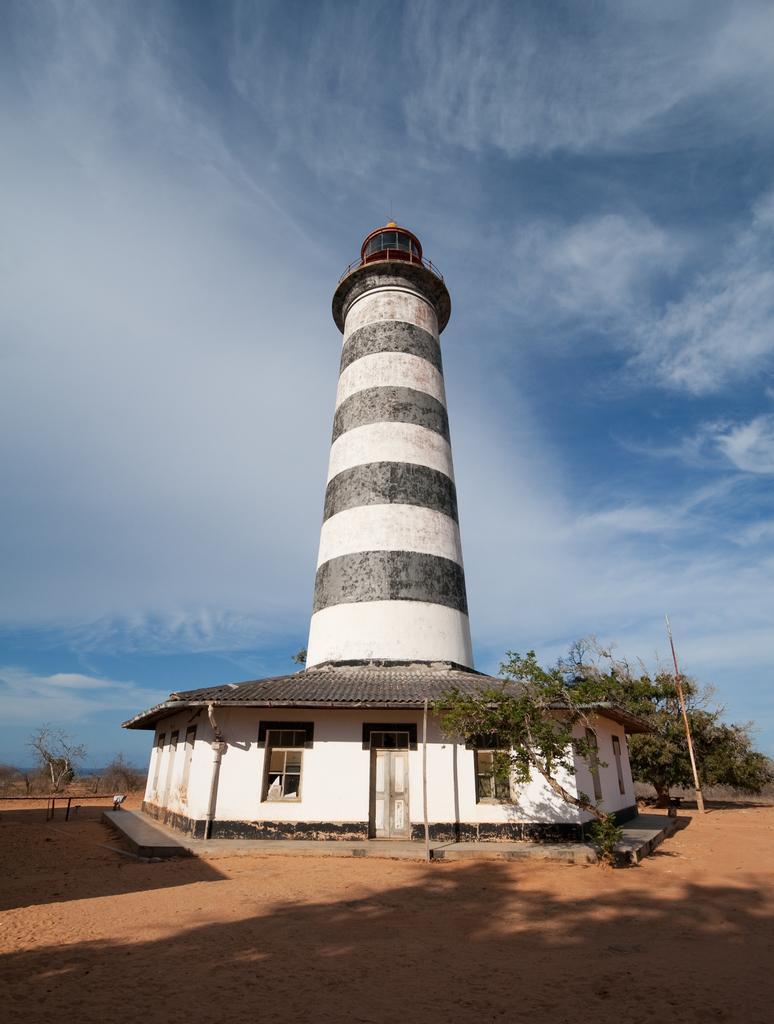Describe this image in one or two sentences. This image is taken outdoors. At the top of the image there is a sky with clouds. At the bottom of the image there is a ground. In the middle of the image there is a house and tower is a tower and there are a few trees and plants. 